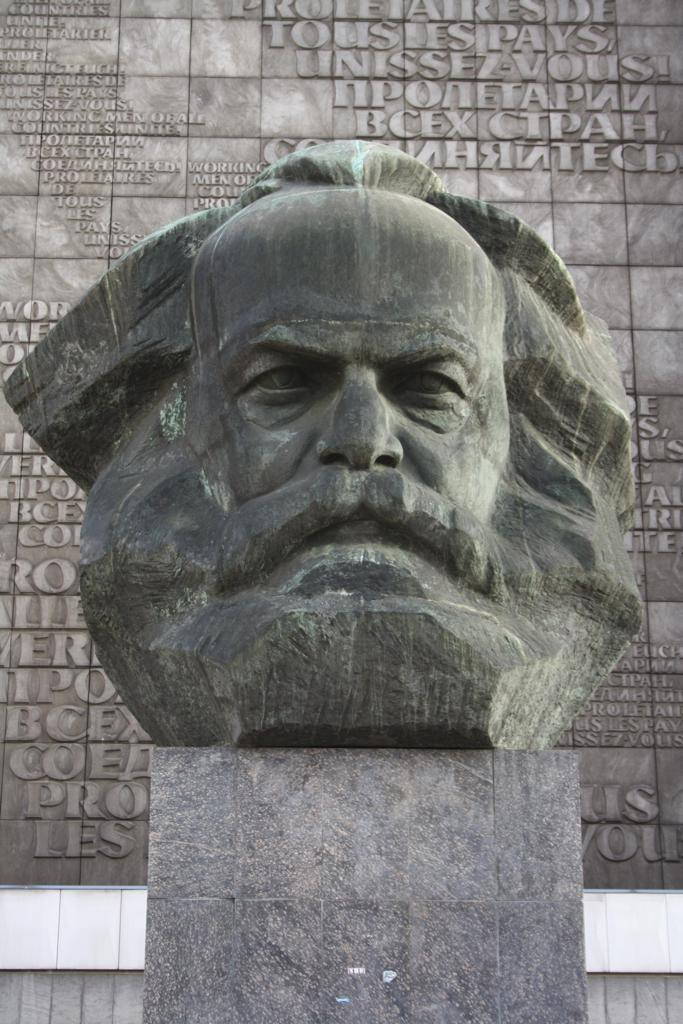What is the main subject of the image? There is a statue of a man's head in the image. What can be seen in the background of the image? There is a wall in the background of the image. What is written or depicted on the wall? There are texts on the wall. What type of pain is the man's head experiencing in the image? There is no indication of pain in the image; it simply depicts a statue of a man's head. What nation does the man's head represent in the image? The image does not provide any information about the nationality or origin of the man's head. 